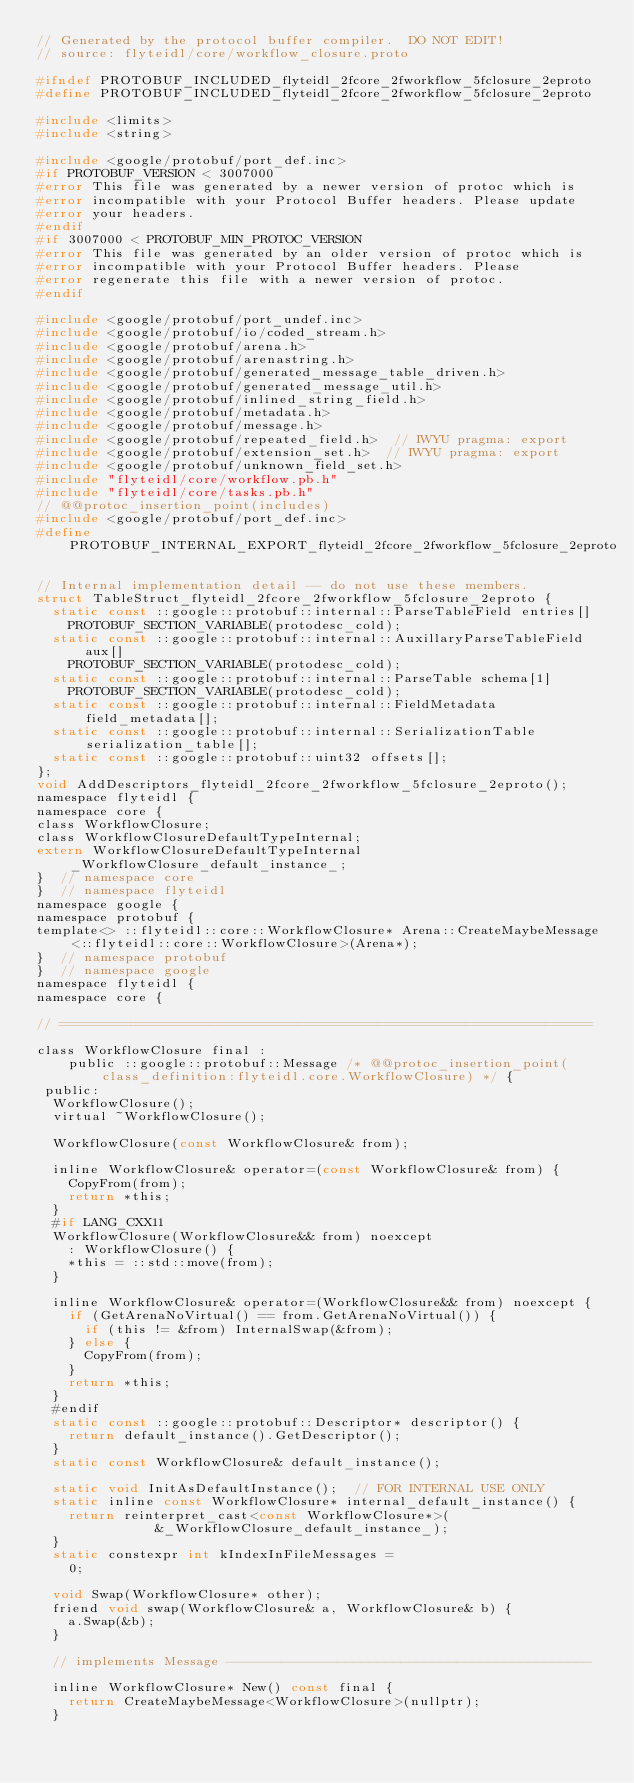Convert code to text. <code><loc_0><loc_0><loc_500><loc_500><_C_>// Generated by the protocol buffer compiler.  DO NOT EDIT!
// source: flyteidl/core/workflow_closure.proto

#ifndef PROTOBUF_INCLUDED_flyteidl_2fcore_2fworkflow_5fclosure_2eproto
#define PROTOBUF_INCLUDED_flyteidl_2fcore_2fworkflow_5fclosure_2eproto

#include <limits>
#include <string>

#include <google/protobuf/port_def.inc>
#if PROTOBUF_VERSION < 3007000
#error This file was generated by a newer version of protoc which is
#error incompatible with your Protocol Buffer headers. Please update
#error your headers.
#endif
#if 3007000 < PROTOBUF_MIN_PROTOC_VERSION
#error This file was generated by an older version of protoc which is
#error incompatible with your Protocol Buffer headers. Please
#error regenerate this file with a newer version of protoc.
#endif

#include <google/protobuf/port_undef.inc>
#include <google/protobuf/io/coded_stream.h>
#include <google/protobuf/arena.h>
#include <google/protobuf/arenastring.h>
#include <google/protobuf/generated_message_table_driven.h>
#include <google/protobuf/generated_message_util.h>
#include <google/protobuf/inlined_string_field.h>
#include <google/protobuf/metadata.h>
#include <google/protobuf/message.h>
#include <google/protobuf/repeated_field.h>  // IWYU pragma: export
#include <google/protobuf/extension_set.h>  // IWYU pragma: export
#include <google/protobuf/unknown_field_set.h>
#include "flyteidl/core/workflow.pb.h"
#include "flyteidl/core/tasks.pb.h"
// @@protoc_insertion_point(includes)
#include <google/protobuf/port_def.inc>
#define PROTOBUF_INTERNAL_EXPORT_flyteidl_2fcore_2fworkflow_5fclosure_2eproto

// Internal implementation detail -- do not use these members.
struct TableStruct_flyteidl_2fcore_2fworkflow_5fclosure_2eproto {
  static const ::google::protobuf::internal::ParseTableField entries[]
    PROTOBUF_SECTION_VARIABLE(protodesc_cold);
  static const ::google::protobuf::internal::AuxillaryParseTableField aux[]
    PROTOBUF_SECTION_VARIABLE(protodesc_cold);
  static const ::google::protobuf::internal::ParseTable schema[1]
    PROTOBUF_SECTION_VARIABLE(protodesc_cold);
  static const ::google::protobuf::internal::FieldMetadata field_metadata[];
  static const ::google::protobuf::internal::SerializationTable serialization_table[];
  static const ::google::protobuf::uint32 offsets[];
};
void AddDescriptors_flyteidl_2fcore_2fworkflow_5fclosure_2eproto();
namespace flyteidl {
namespace core {
class WorkflowClosure;
class WorkflowClosureDefaultTypeInternal;
extern WorkflowClosureDefaultTypeInternal _WorkflowClosure_default_instance_;
}  // namespace core
}  // namespace flyteidl
namespace google {
namespace protobuf {
template<> ::flyteidl::core::WorkflowClosure* Arena::CreateMaybeMessage<::flyteidl::core::WorkflowClosure>(Arena*);
}  // namespace protobuf
}  // namespace google
namespace flyteidl {
namespace core {

// ===================================================================

class WorkflowClosure final :
    public ::google::protobuf::Message /* @@protoc_insertion_point(class_definition:flyteidl.core.WorkflowClosure) */ {
 public:
  WorkflowClosure();
  virtual ~WorkflowClosure();

  WorkflowClosure(const WorkflowClosure& from);

  inline WorkflowClosure& operator=(const WorkflowClosure& from) {
    CopyFrom(from);
    return *this;
  }
  #if LANG_CXX11
  WorkflowClosure(WorkflowClosure&& from) noexcept
    : WorkflowClosure() {
    *this = ::std::move(from);
  }

  inline WorkflowClosure& operator=(WorkflowClosure&& from) noexcept {
    if (GetArenaNoVirtual() == from.GetArenaNoVirtual()) {
      if (this != &from) InternalSwap(&from);
    } else {
      CopyFrom(from);
    }
    return *this;
  }
  #endif
  static const ::google::protobuf::Descriptor* descriptor() {
    return default_instance().GetDescriptor();
  }
  static const WorkflowClosure& default_instance();

  static void InitAsDefaultInstance();  // FOR INTERNAL USE ONLY
  static inline const WorkflowClosure* internal_default_instance() {
    return reinterpret_cast<const WorkflowClosure*>(
               &_WorkflowClosure_default_instance_);
  }
  static constexpr int kIndexInFileMessages =
    0;

  void Swap(WorkflowClosure* other);
  friend void swap(WorkflowClosure& a, WorkflowClosure& b) {
    a.Swap(&b);
  }

  // implements Message ----------------------------------------------

  inline WorkflowClosure* New() const final {
    return CreateMaybeMessage<WorkflowClosure>(nullptr);
  }
</code> 